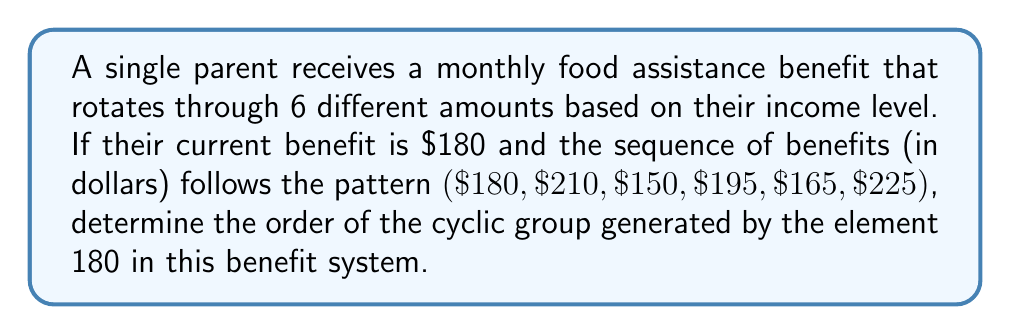Can you answer this question? To solve this problem, we need to understand the concept of cyclic groups and how to determine their order. Let's approach this step-by-step:

1) First, let's identify the group: 
   The group is the set of all possible benefit amounts: $G = \{180, 210, 150, 195, 165, 225\}$

2) The element we're focusing on is 180. Let's call this element $a$.

3) To find the order of the cyclic subgroup generated by $a$, we need to see how many times we need to apply the operation (in this case, moving to the next element in the sequence) before we return to 180.

4) Let's list out the powers of $a$:
   $a^1 = 180$
   $a^2 = 210$
   $a^3 = 150$
   $a^4 = 195$
   $a^5 = 165$
   $a^6 = 225$
   $a^7 = 180$ (We're back to where we started)

5) We see that it takes 6 applications of the operation to return to 180.

6) Therefore, the order of the cyclic subgroup generated by 180 is 6.

In group theory terms, we would write this as $|\langle 180 \rangle| = 6$, where $\langle 180 \rangle$ denotes the cyclic subgroup generated by 180.

Note: In this case, the order of the subgroup is equal to the order of the entire group, which means that 180 is a generator for the whole group. This makes sense because starting from 180, we can generate all other elements in the group by repeated application of the "next element" operation.
Answer: The order of the cyclic group generated by the element 180 is 6. 